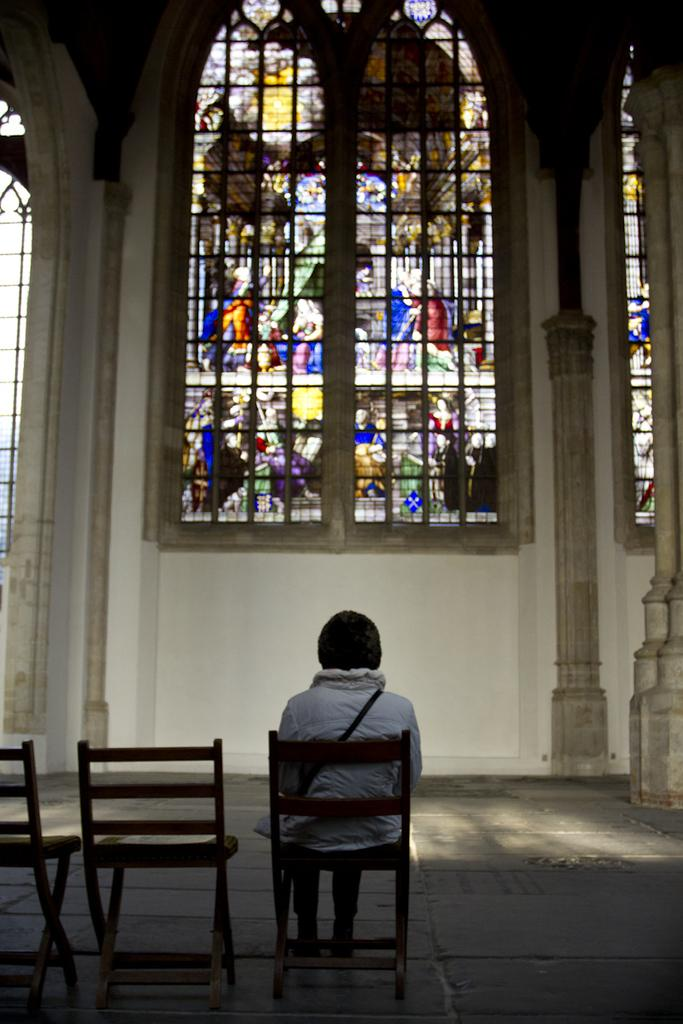What is the person in the image doing? There is a person sitting on a chair in the image. How many chairs are visible in the image? There are chairs in the image. What can be seen on the floor in the image? The floor is visible in the image. What is visible in the background of the image? There is a wall, a window, and a pillar in the background of the image. What type of yak can be seen reading a book in the image? There is no yak or book present in the image. How does the person roll around in the image? The person does not roll around in the image; they are sitting on a chair. 